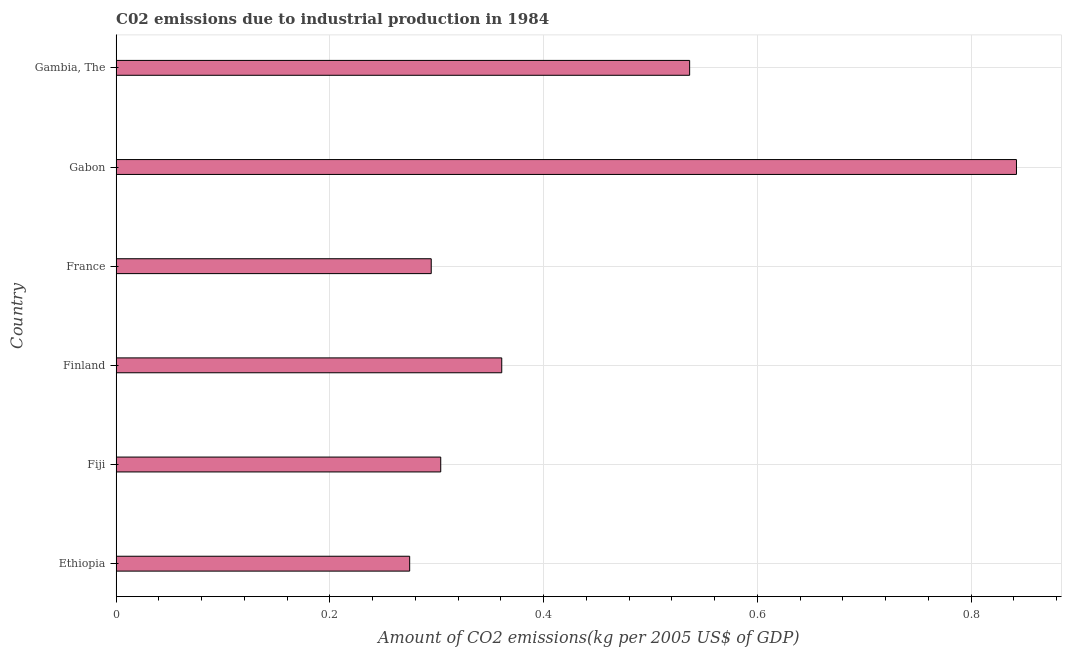Does the graph contain any zero values?
Provide a succinct answer. No. Does the graph contain grids?
Give a very brief answer. Yes. What is the title of the graph?
Offer a terse response. C02 emissions due to industrial production in 1984. What is the label or title of the X-axis?
Offer a very short reply. Amount of CO2 emissions(kg per 2005 US$ of GDP). What is the amount of co2 emissions in Ethiopia?
Offer a very short reply. 0.27. Across all countries, what is the maximum amount of co2 emissions?
Your answer should be very brief. 0.84. Across all countries, what is the minimum amount of co2 emissions?
Make the answer very short. 0.27. In which country was the amount of co2 emissions maximum?
Make the answer very short. Gabon. In which country was the amount of co2 emissions minimum?
Provide a succinct answer. Ethiopia. What is the sum of the amount of co2 emissions?
Your response must be concise. 2.61. What is the difference between the amount of co2 emissions in Fiji and France?
Ensure brevity in your answer.  0.01. What is the average amount of co2 emissions per country?
Your answer should be compact. 0.43. What is the median amount of co2 emissions?
Your answer should be very brief. 0.33. In how many countries, is the amount of co2 emissions greater than 0.28 kg per 2005 US$ of GDP?
Keep it short and to the point. 5. What is the ratio of the amount of co2 emissions in Ethiopia to that in Gabon?
Make the answer very short. 0.33. Is the amount of co2 emissions in France less than that in Gabon?
Provide a succinct answer. Yes. Is the difference between the amount of co2 emissions in Ethiopia and Finland greater than the difference between any two countries?
Your answer should be compact. No. What is the difference between the highest and the second highest amount of co2 emissions?
Give a very brief answer. 0.31. What is the difference between the highest and the lowest amount of co2 emissions?
Make the answer very short. 0.57. In how many countries, is the amount of co2 emissions greater than the average amount of co2 emissions taken over all countries?
Provide a short and direct response. 2. How many bars are there?
Keep it short and to the point. 6. Are the values on the major ticks of X-axis written in scientific E-notation?
Ensure brevity in your answer.  No. What is the Amount of CO2 emissions(kg per 2005 US$ of GDP) of Ethiopia?
Provide a short and direct response. 0.27. What is the Amount of CO2 emissions(kg per 2005 US$ of GDP) of Fiji?
Offer a very short reply. 0.3. What is the Amount of CO2 emissions(kg per 2005 US$ of GDP) of Finland?
Keep it short and to the point. 0.36. What is the Amount of CO2 emissions(kg per 2005 US$ of GDP) of France?
Your answer should be compact. 0.29. What is the Amount of CO2 emissions(kg per 2005 US$ of GDP) in Gabon?
Offer a very short reply. 0.84. What is the Amount of CO2 emissions(kg per 2005 US$ of GDP) in Gambia, The?
Offer a terse response. 0.54. What is the difference between the Amount of CO2 emissions(kg per 2005 US$ of GDP) in Ethiopia and Fiji?
Give a very brief answer. -0.03. What is the difference between the Amount of CO2 emissions(kg per 2005 US$ of GDP) in Ethiopia and Finland?
Ensure brevity in your answer.  -0.09. What is the difference between the Amount of CO2 emissions(kg per 2005 US$ of GDP) in Ethiopia and France?
Your answer should be compact. -0.02. What is the difference between the Amount of CO2 emissions(kg per 2005 US$ of GDP) in Ethiopia and Gabon?
Make the answer very short. -0.57. What is the difference between the Amount of CO2 emissions(kg per 2005 US$ of GDP) in Ethiopia and Gambia, The?
Offer a very short reply. -0.26. What is the difference between the Amount of CO2 emissions(kg per 2005 US$ of GDP) in Fiji and Finland?
Your response must be concise. -0.06. What is the difference between the Amount of CO2 emissions(kg per 2005 US$ of GDP) in Fiji and France?
Ensure brevity in your answer.  0.01. What is the difference between the Amount of CO2 emissions(kg per 2005 US$ of GDP) in Fiji and Gabon?
Your answer should be compact. -0.54. What is the difference between the Amount of CO2 emissions(kg per 2005 US$ of GDP) in Fiji and Gambia, The?
Offer a very short reply. -0.23. What is the difference between the Amount of CO2 emissions(kg per 2005 US$ of GDP) in Finland and France?
Your response must be concise. 0.07. What is the difference between the Amount of CO2 emissions(kg per 2005 US$ of GDP) in Finland and Gabon?
Provide a succinct answer. -0.48. What is the difference between the Amount of CO2 emissions(kg per 2005 US$ of GDP) in Finland and Gambia, The?
Your answer should be compact. -0.18. What is the difference between the Amount of CO2 emissions(kg per 2005 US$ of GDP) in France and Gabon?
Offer a very short reply. -0.55. What is the difference between the Amount of CO2 emissions(kg per 2005 US$ of GDP) in France and Gambia, The?
Make the answer very short. -0.24. What is the difference between the Amount of CO2 emissions(kg per 2005 US$ of GDP) in Gabon and Gambia, The?
Offer a terse response. 0.31. What is the ratio of the Amount of CO2 emissions(kg per 2005 US$ of GDP) in Ethiopia to that in Fiji?
Offer a very short reply. 0.9. What is the ratio of the Amount of CO2 emissions(kg per 2005 US$ of GDP) in Ethiopia to that in Finland?
Provide a short and direct response. 0.76. What is the ratio of the Amount of CO2 emissions(kg per 2005 US$ of GDP) in Ethiopia to that in France?
Make the answer very short. 0.93. What is the ratio of the Amount of CO2 emissions(kg per 2005 US$ of GDP) in Ethiopia to that in Gabon?
Offer a terse response. 0.33. What is the ratio of the Amount of CO2 emissions(kg per 2005 US$ of GDP) in Ethiopia to that in Gambia, The?
Offer a terse response. 0.51. What is the ratio of the Amount of CO2 emissions(kg per 2005 US$ of GDP) in Fiji to that in Finland?
Offer a terse response. 0.84. What is the ratio of the Amount of CO2 emissions(kg per 2005 US$ of GDP) in Fiji to that in France?
Offer a very short reply. 1.03. What is the ratio of the Amount of CO2 emissions(kg per 2005 US$ of GDP) in Fiji to that in Gabon?
Your answer should be very brief. 0.36. What is the ratio of the Amount of CO2 emissions(kg per 2005 US$ of GDP) in Fiji to that in Gambia, The?
Provide a succinct answer. 0.57. What is the ratio of the Amount of CO2 emissions(kg per 2005 US$ of GDP) in Finland to that in France?
Give a very brief answer. 1.22. What is the ratio of the Amount of CO2 emissions(kg per 2005 US$ of GDP) in Finland to that in Gabon?
Give a very brief answer. 0.43. What is the ratio of the Amount of CO2 emissions(kg per 2005 US$ of GDP) in Finland to that in Gambia, The?
Ensure brevity in your answer.  0.67. What is the ratio of the Amount of CO2 emissions(kg per 2005 US$ of GDP) in France to that in Gambia, The?
Provide a succinct answer. 0.55. What is the ratio of the Amount of CO2 emissions(kg per 2005 US$ of GDP) in Gabon to that in Gambia, The?
Your answer should be very brief. 1.57. 